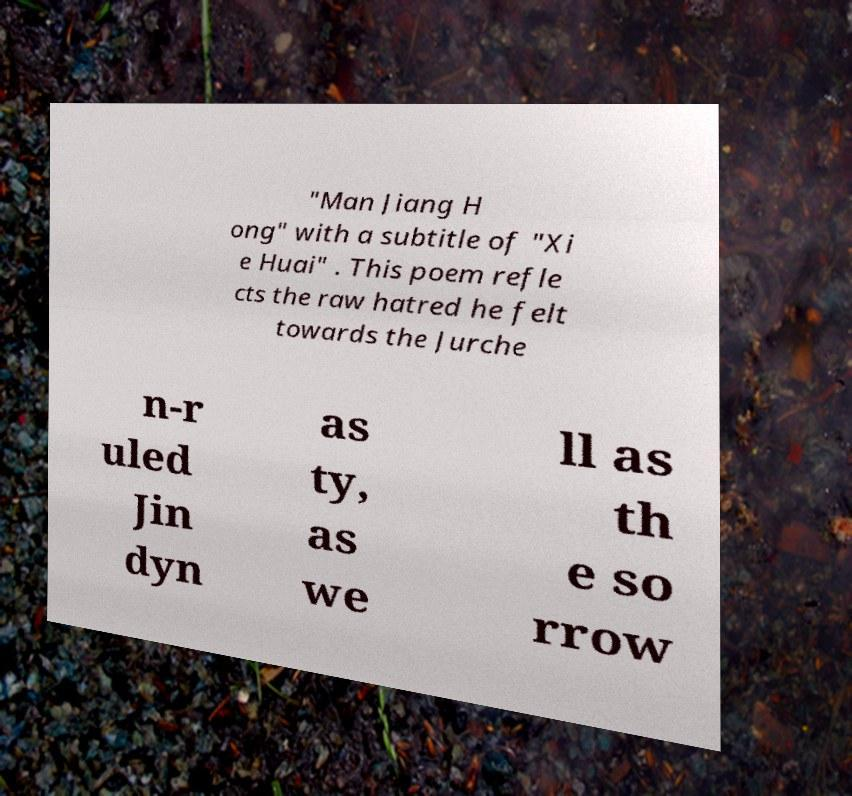What messages or text are displayed in this image? I need them in a readable, typed format. "Man Jiang H ong" with a subtitle of "Xi e Huai" . This poem refle cts the raw hatred he felt towards the Jurche n-r uled Jin dyn as ty, as we ll as th e so rrow 